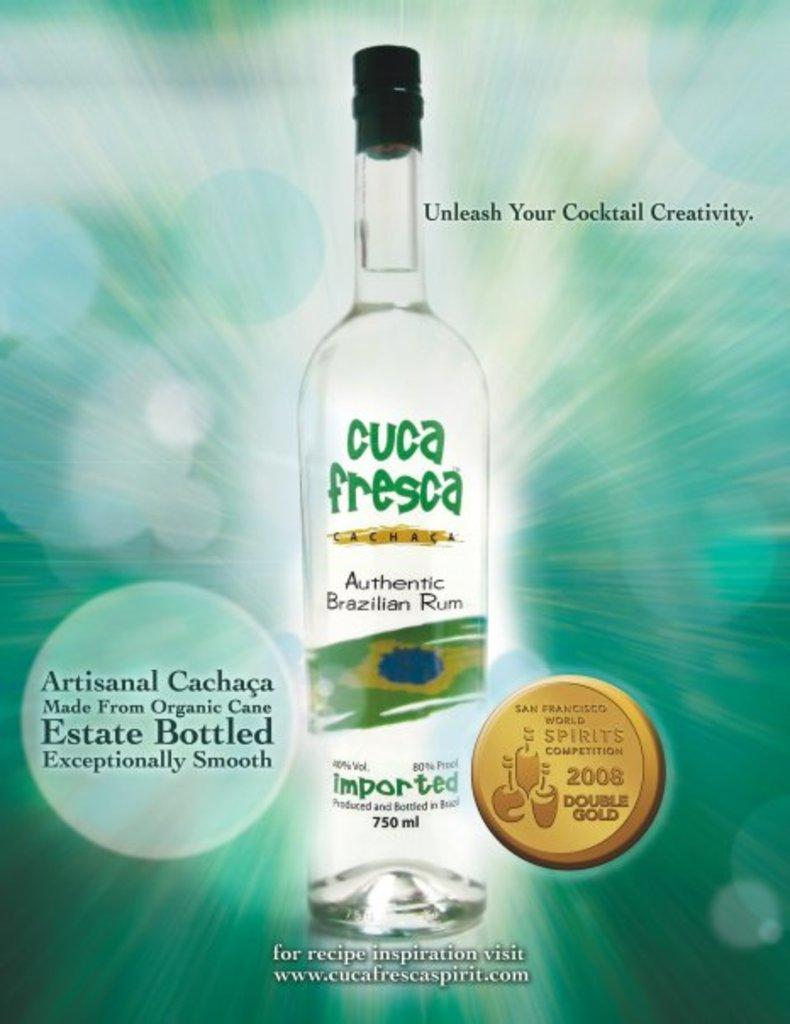<image>
Describe the image concisely. An advertisement for Cuca Fresca Authentic Brazilian Rum. 